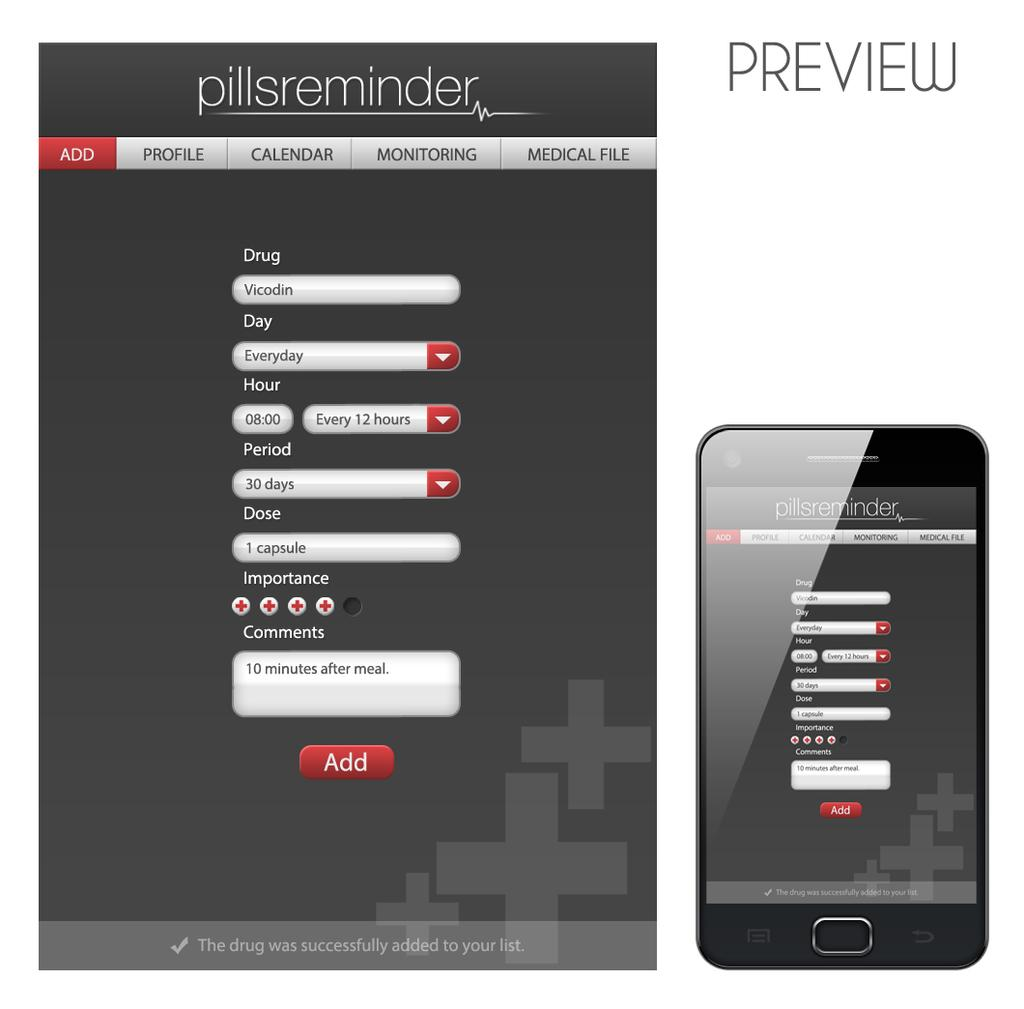<image>
Give a short and clear explanation of the subsequent image. Two versions of a pillsreminder screen show the add feature. 